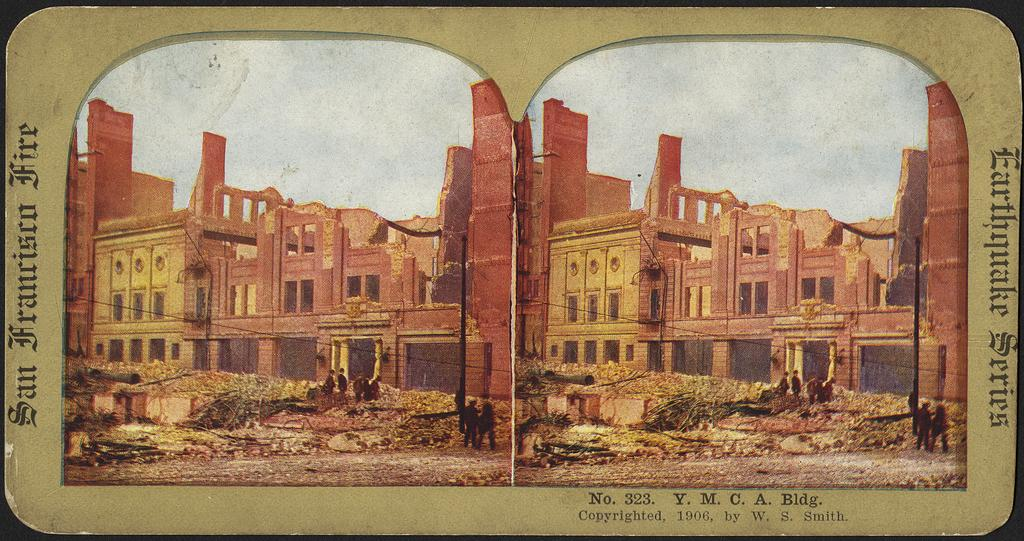What is the main subject of the image? There is a poster in the image. What type of images are on the poster? The poster contains images of buildings. Is there any text on the poster? Yes, there is text at the bottom of the image. What time of day is the discussion taking place in the image? There is no discussion taking place in the image; it only features a poster with images of buildings and text. 